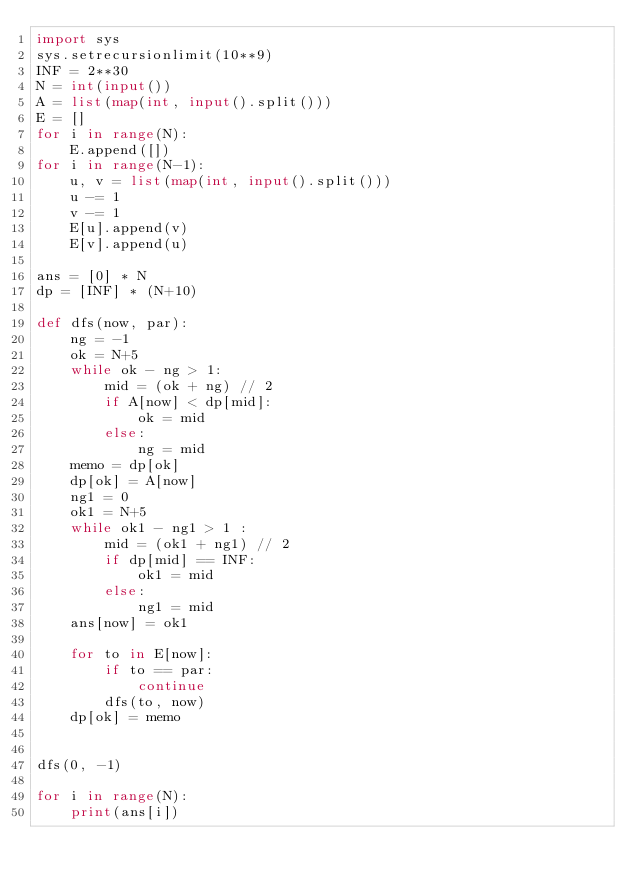Convert code to text. <code><loc_0><loc_0><loc_500><loc_500><_Python_>import sys
sys.setrecursionlimit(10**9)
INF = 2**30
N = int(input())
A = list(map(int, input().split()))
E = []
for i in range(N):
    E.append([])
for i in range(N-1):
    u, v = list(map(int, input().split()))
    u -= 1
    v -= 1
    E[u].append(v)
    E[v].append(u)

ans = [0] * N
dp = [INF] * (N+10)

def dfs(now, par):
    ng = -1
    ok = N+5
    while ok - ng > 1:
        mid = (ok + ng) // 2
        if A[now] < dp[mid]:
            ok = mid
        else:
            ng = mid
    memo = dp[ok]
    dp[ok] = A[now]
    ng1 = 0
    ok1 = N+5
    while ok1 - ng1 > 1 :
        mid = (ok1 + ng1) // 2
        if dp[mid] == INF:
            ok1 = mid
        else:
            ng1 = mid
    ans[now] = ok1

    for to in E[now]:
        if to == par:
            continue
        dfs(to, now)
    dp[ok] = memo


dfs(0, -1)

for i in range(N):
    print(ans[i])
</code> 